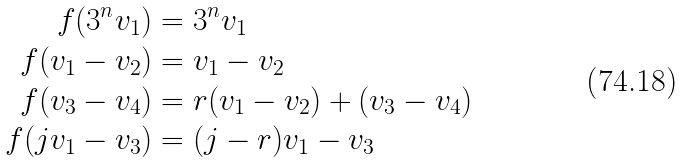Convert formula to latex. <formula><loc_0><loc_0><loc_500><loc_500>f ( 3 ^ { n } v _ { 1 } ) & = 3 ^ { n } v _ { 1 } \\ f ( v _ { 1 } - v _ { 2 } ) & = v _ { 1 } - v _ { 2 } \\ f ( v _ { 3 } - v _ { 4 } ) & = r ( v _ { 1 } - v _ { 2 } ) + ( v _ { 3 } - v _ { 4 } ) \\ f ( j v _ { 1 } - v _ { 3 } ) & = ( j - r ) v _ { 1 } - v _ { 3 }</formula> 